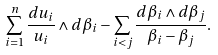Convert formula to latex. <formula><loc_0><loc_0><loc_500><loc_500>\sum _ { i = 1 } ^ { n } \frac { d u _ { i } } { u _ { i } } \wedge d \beta _ { i } - \sum _ { i < j } \frac { d \beta _ { i } \wedge d \beta _ { j } } { \beta _ { i } - \beta _ { j } } .</formula> 